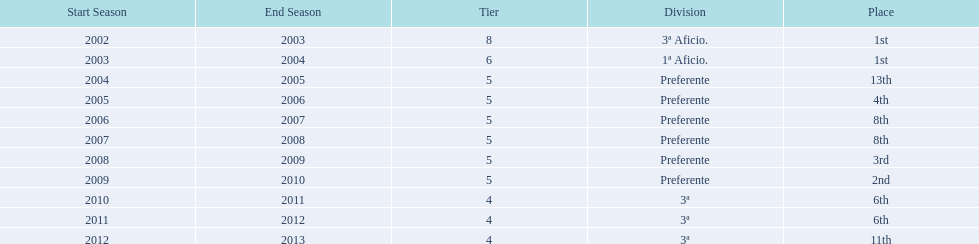How many times did  internacional de madrid cf come in 6th place? 6th, 6th. What is the first season that the team came in 6th place? 2010/11. Which season after the first did they place in 6th again? 2011/12. 